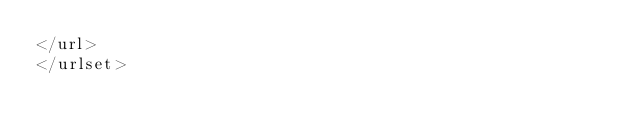Convert code to text. <code><loc_0><loc_0><loc_500><loc_500><_XML_></url>
</urlset></code> 